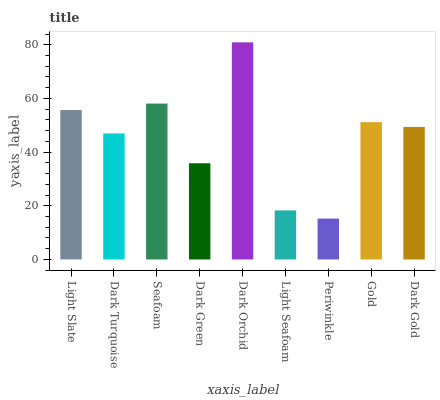Is Periwinkle the minimum?
Answer yes or no. Yes. Is Dark Orchid the maximum?
Answer yes or no. Yes. Is Dark Turquoise the minimum?
Answer yes or no. No. Is Dark Turquoise the maximum?
Answer yes or no. No. Is Light Slate greater than Dark Turquoise?
Answer yes or no. Yes. Is Dark Turquoise less than Light Slate?
Answer yes or no. Yes. Is Dark Turquoise greater than Light Slate?
Answer yes or no. No. Is Light Slate less than Dark Turquoise?
Answer yes or no. No. Is Dark Gold the high median?
Answer yes or no. Yes. Is Dark Gold the low median?
Answer yes or no. Yes. Is Dark Turquoise the high median?
Answer yes or no. No. Is Dark Turquoise the low median?
Answer yes or no. No. 